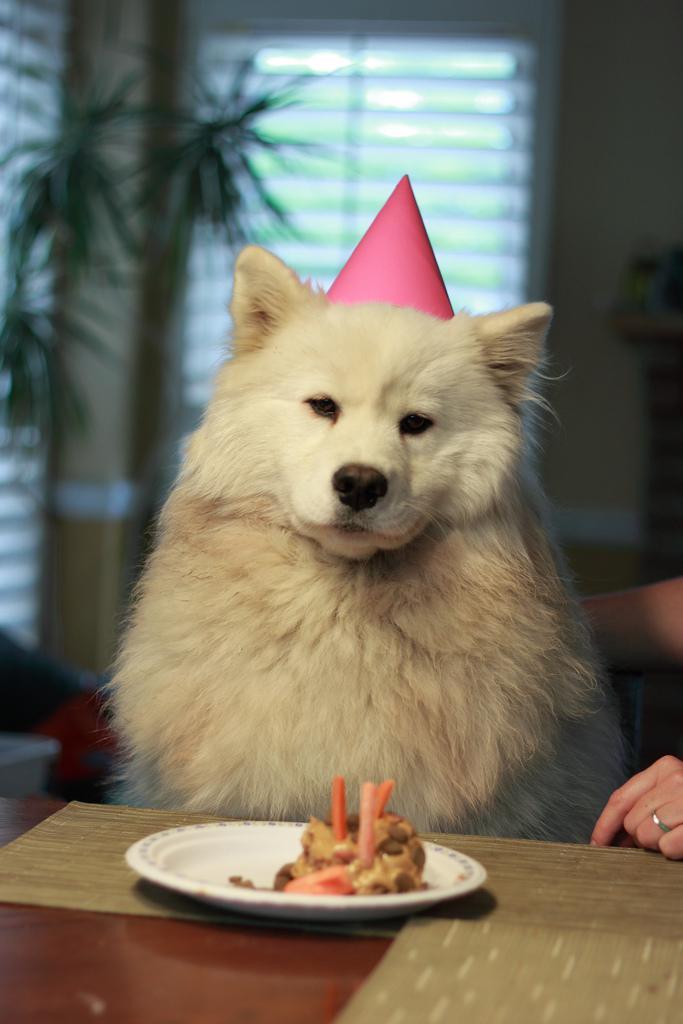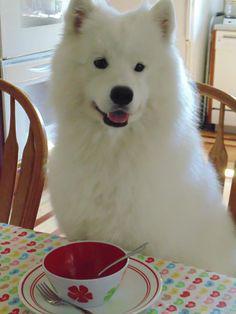The first image is the image on the left, the second image is the image on the right. Given the left and right images, does the statement "There is a total of 2 Samoyed's sitting at a table." hold true? Answer yes or no. Yes. The first image is the image on the left, the second image is the image on the right. For the images shown, is this caption "a dog is sitting at the kitchen table" true? Answer yes or no. Yes. 